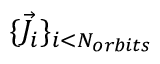Convert formula to latex. <formula><loc_0><loc_0><loc_500><loc_500>\{ \vec { J } _ { i } \} _ { i < N _ { o r b i t s } }</formula> 